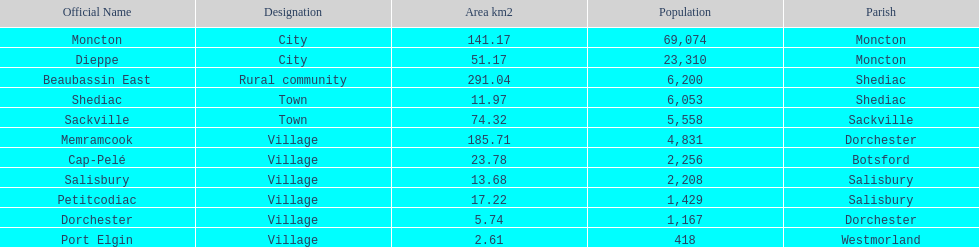Which city has the least area Port Elgin. 